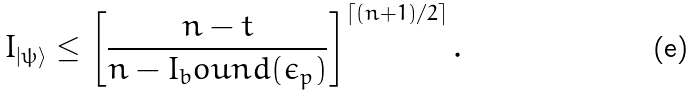Convert formula to latex. <formula><loc_0><loc_0><loc_500><loc_500>I _ { | \psi \rangle } \leq \left [ \frac { n - t } { n - I _ { b } o u n d ( \epsilon _ { p } ) } \right ] ^ { \left \lceil ( n + 1 ) / 2 \right \rceil } .</formula> 